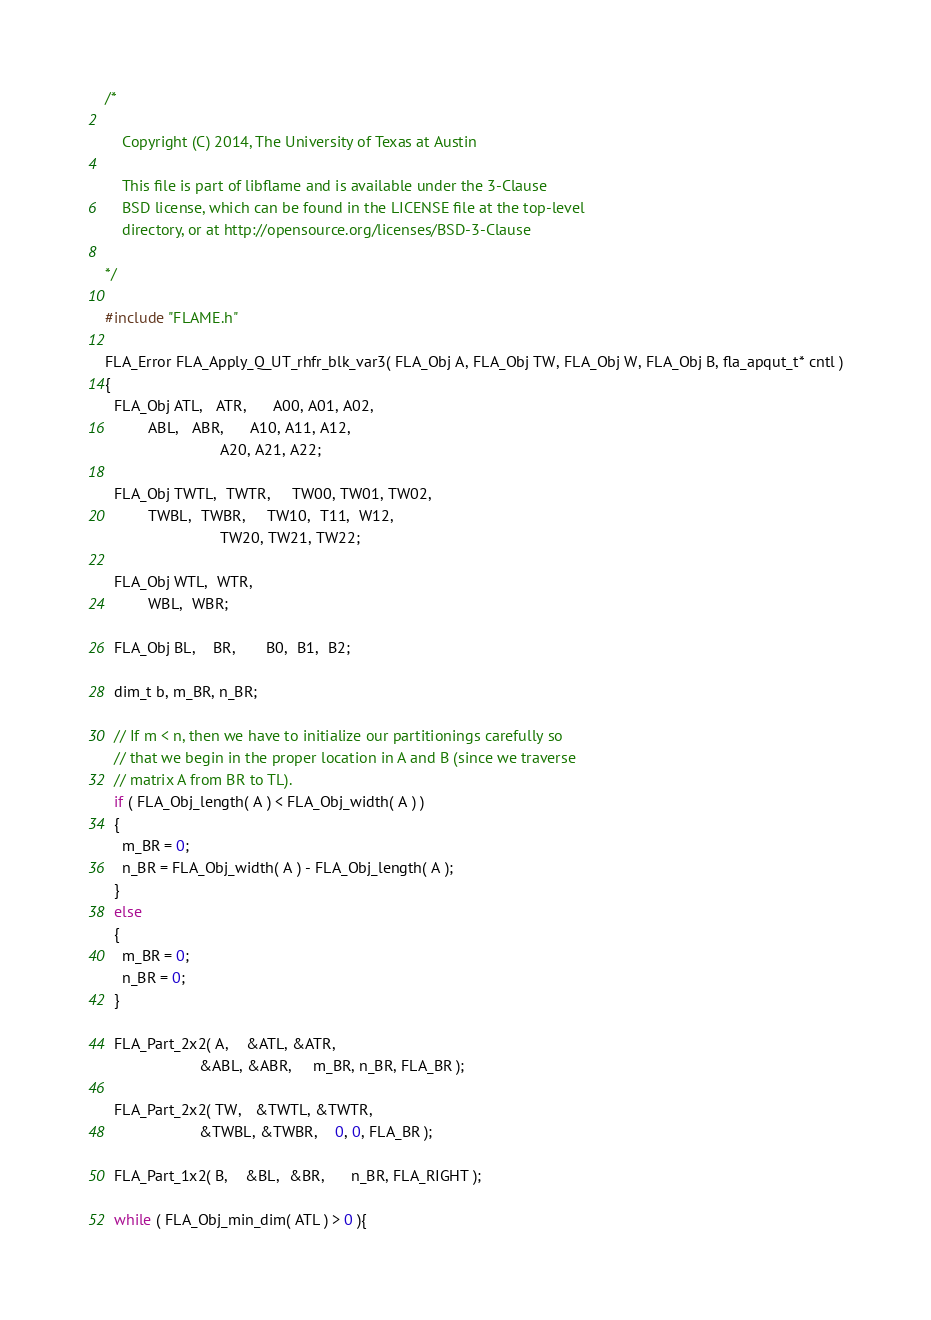<code> <loc_0><loc_0><loc_500><loc_500><_C_>/*

    Copyright (C) 2014, The University of Texas at Austin

    This file is part of libflame and is available under the 3-Clause
    BSD license, which can be found in the LICENSE file at the top-level
    directory, or at http://opensource.org/licenses/BSD-3-Clause

*/

#include "FLAME.h"

FLA_Error FLA_Apply_Q_UT_rhfr_blk_var3( FLA_Obj A, FLA_Obj TW, FLA_Obj W, FLA_Obj B, fla_apqut_t* cntl )
{
  FLA_Obj ATL,   ATR,      A00, A01, A02, 
          ABL,   ABR,      A10, A11, A12,
                           A20, A21, A22;

  FLA_Obj TWTL,  TWTR,     TW00, TW01, TW02,
          TWBL,  TWBR,     TW10,  T11,  W12,
                           TW20, TW21, TW22;

  FLA_Obj WTL,  WTR,
          WBL,  WBR;

  FLA_Obj BL,    BR,       B0,  B1,  B2;

  dim_t b, m_BR, n_BR;

  // If m < n, then we have to initialize our partitionings carefully so
  // that we begin in the proper location in A and B (since we traverse
  // matrix A from BR to TL).
  if ( FLA_Obj_length( A ) < FLA_Obj_width( A ) )
  {
    m_BR = 0;
    n_BR = FLA_Obj_width( A ) - FLA_Obj_length( A );
  }
  else
  {
    m_BR = 0;
    n_BR = 0;
  }

  FLA_Part_2x2( A,    &ATL, &ATR,
                      &ABL, &ABR,     m_BR, n_BR, FLA_BR );

  FLA_Part_2x2( TW,   &TWTL, &TWTR,    
                      &TWBL, &TWBR,    0, 0, FLA_BR );

  FLA_Part_1x2( B,    &BL,  &BR,      n_BR, FLA_RIGHT );

  while ( FLA_Obj_min_dim( ATL ) > 0 ){
</code> 